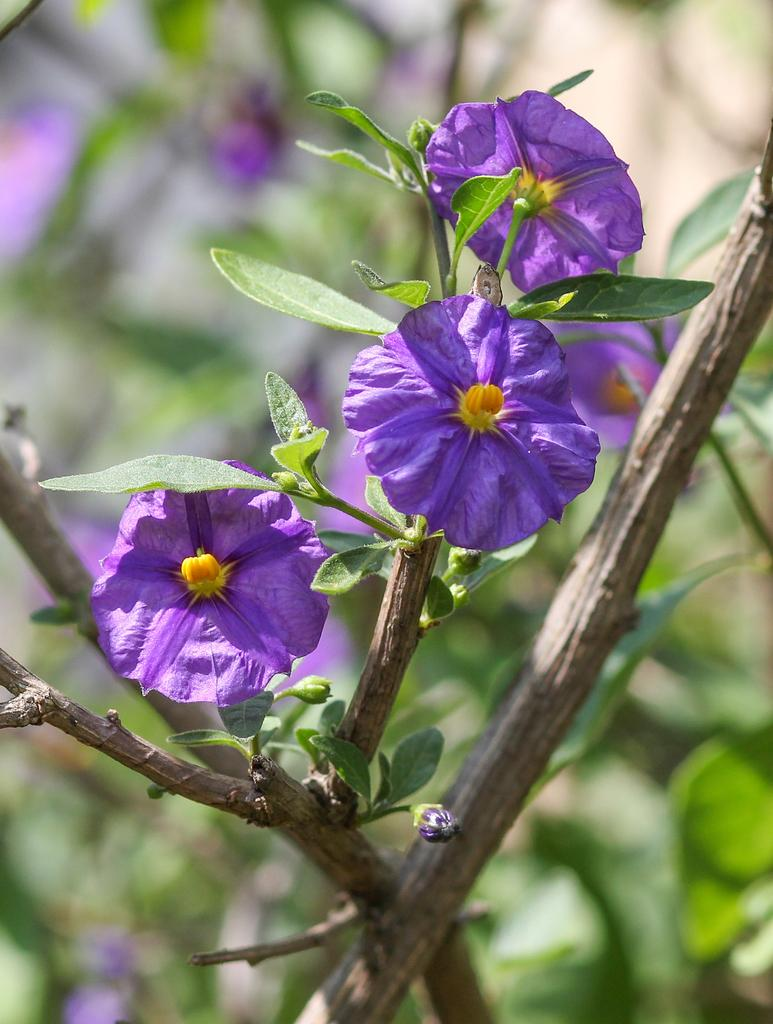What type of plants can be seen in the image? There are flowers in the image. Can you describe any specific parts of the flowers that are visible? The stems of the flowers are visible in the image. What type of underwear can be seen on the flowers in the image? There is no underwear present on the flowers in the image. What type of rice is being used to hold up the flowers in the image? There is no rice present in the image, and the flowers are not being held up by any such material. 